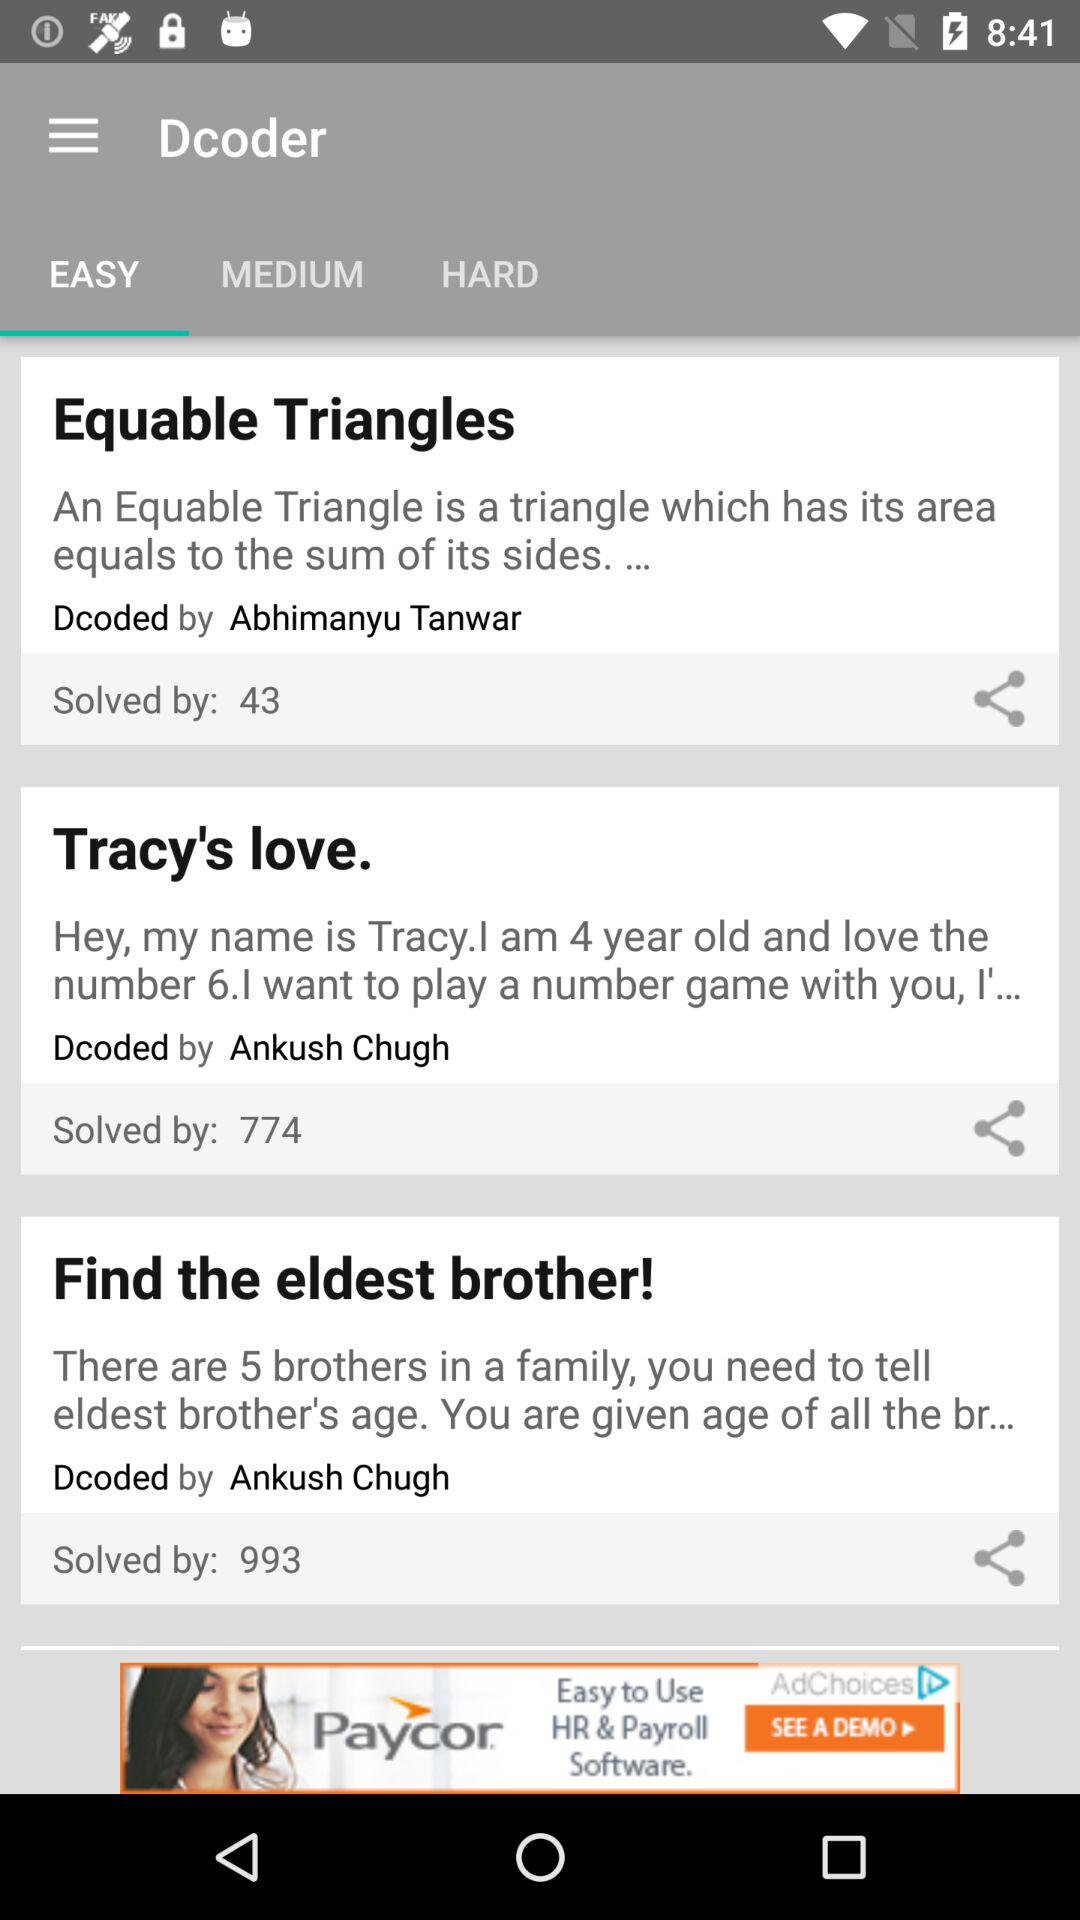How many people have solved "Tracy's love"? "Tracy's love" is solved by 774. 